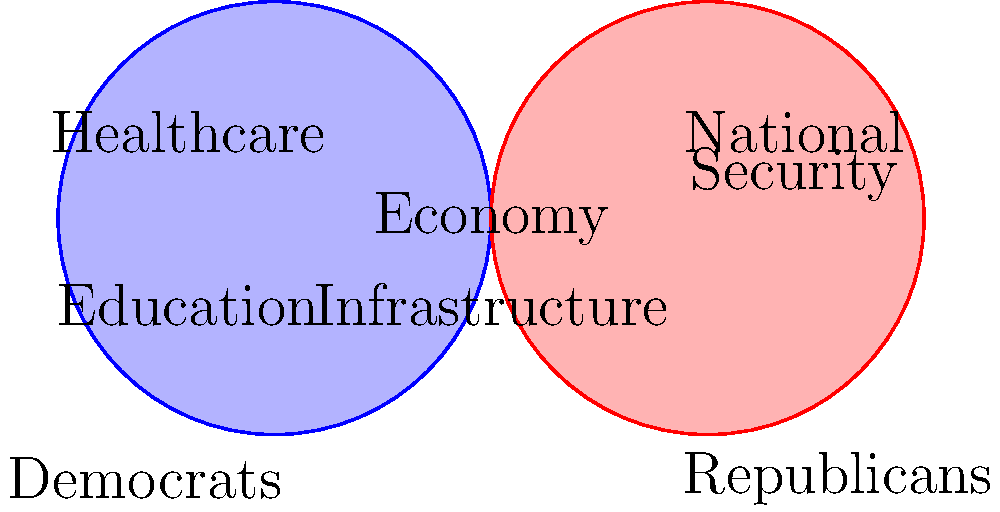Based on the Venn diagram showing policy priorities of Democrats and Republicans, which two issues are shown to have potential for bipartisan cooperation? To answer this question, let's analyze the Venn diagram step-by-step:

1. The left circle (blue) represents Democratic policy priorities.
2. The right circle (red) represents Republican policy priorities.
3. The overlapping area in the middle represents issues that both parties prioritize.

In the diagram, we can see:

4. Democratic priorities (left circle):
   - Healthcare
   - Education

5. Republican priorities (right circle):
   - National Security

6. In the overlapping area, we find two issues:
   - Economy
   - Infrastructure

These two issues in the overlapping area represent policy priorities that both Democrats and Republicans share, indicating potential for bipartisan cooperation.

Therefore, the economy and infrastructure are the two issues shown to have potential for bipartisan cooperation according to this Venn diagram.
Answer: Economy and Infrastructure 